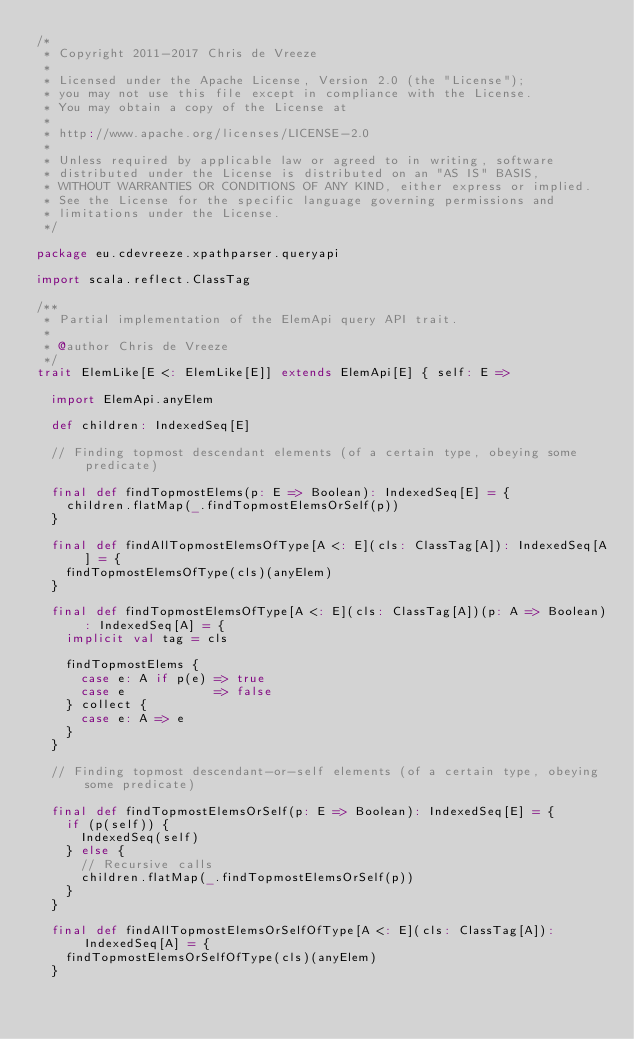<code> <loc_0><loc_0><loc_500><loc_500><_Scala_>/*
 * Copyright 2011-2017 Chris de Vreeze
 *
 * Licensed under the Apache License, Version 2.0 (the "License");
 * you may not use this file except in compliance with the License.
 * You may obtain a copy of the License at
 *
 * http://www.apache.org/licenses/LICENSE-2.0
 *
 * Unless required by applicable law or agreed to in writing, software
 * distributed under the License is distributed on an "AS IS" BASIS,
 * WITHOUT WARRANTIES OR CONDITIONS OF ANY KIND, either express or implied.
 * See the License for the specific language governing permissions and
 * limitations under the License.
 */

package eu.cdevreeze.xpathparser.queryapi

import scala.reflect.ClassTag

/**
 * Partial implementation of the ElemApi query API trait.
 *
 * @author Chris de Vreeze
 */
trait ElemLike[E <: ElemLike[E]] extends ElemApi[E] { self: E =>

  import ElemApi.anyElem

  def children: IndexedSeq[E]

  // Finding topmost descendant elements (of a certain type, obeying some predicate)

  final def findTopmostElems(p: E => Boolean): IndexedSeq[E] = {
    children.flatMap(_.findTopmostElemsOrSelf(p))
  }

  final def findAllTopmostElemsOfType[A <: E](cls: ClassTag[A]): IndexedSeq[A] = {
    findTopmostElemsOfType(cls)(anyElem)
  }

  final def findTopmostElemsOfType[A <: E](cls: ClassTag[A])(p: A => Boolean): IndexedSeq[A] = {
    implicit val tag = cls

    findTopmostElems {
      case e: A if p(e) => true
      case e            => false
    } collect {
      case e: A => e
    }
  }

  // Finding topmost descendant-or-self elements (of a certain type, obeying some predicate)

  final def findTopmostElemsOrSelf(p: E => Boolean): IndexedSeq[E] = {
    if (p(self)) {
      IndexedSeq(self)
    } else {
      // Recursive calls
      children.flatMap(_.findTopmostElemsOrSelf(p))
    }
  }

  final def findAllTopmostElemsOrSelfOfType[A <: E](cls: ClassTag[A]): IndexedSeq[A] = {
    findTopmostElemsOrSelfOfType(cls)(anyElem)
  }
</code> 